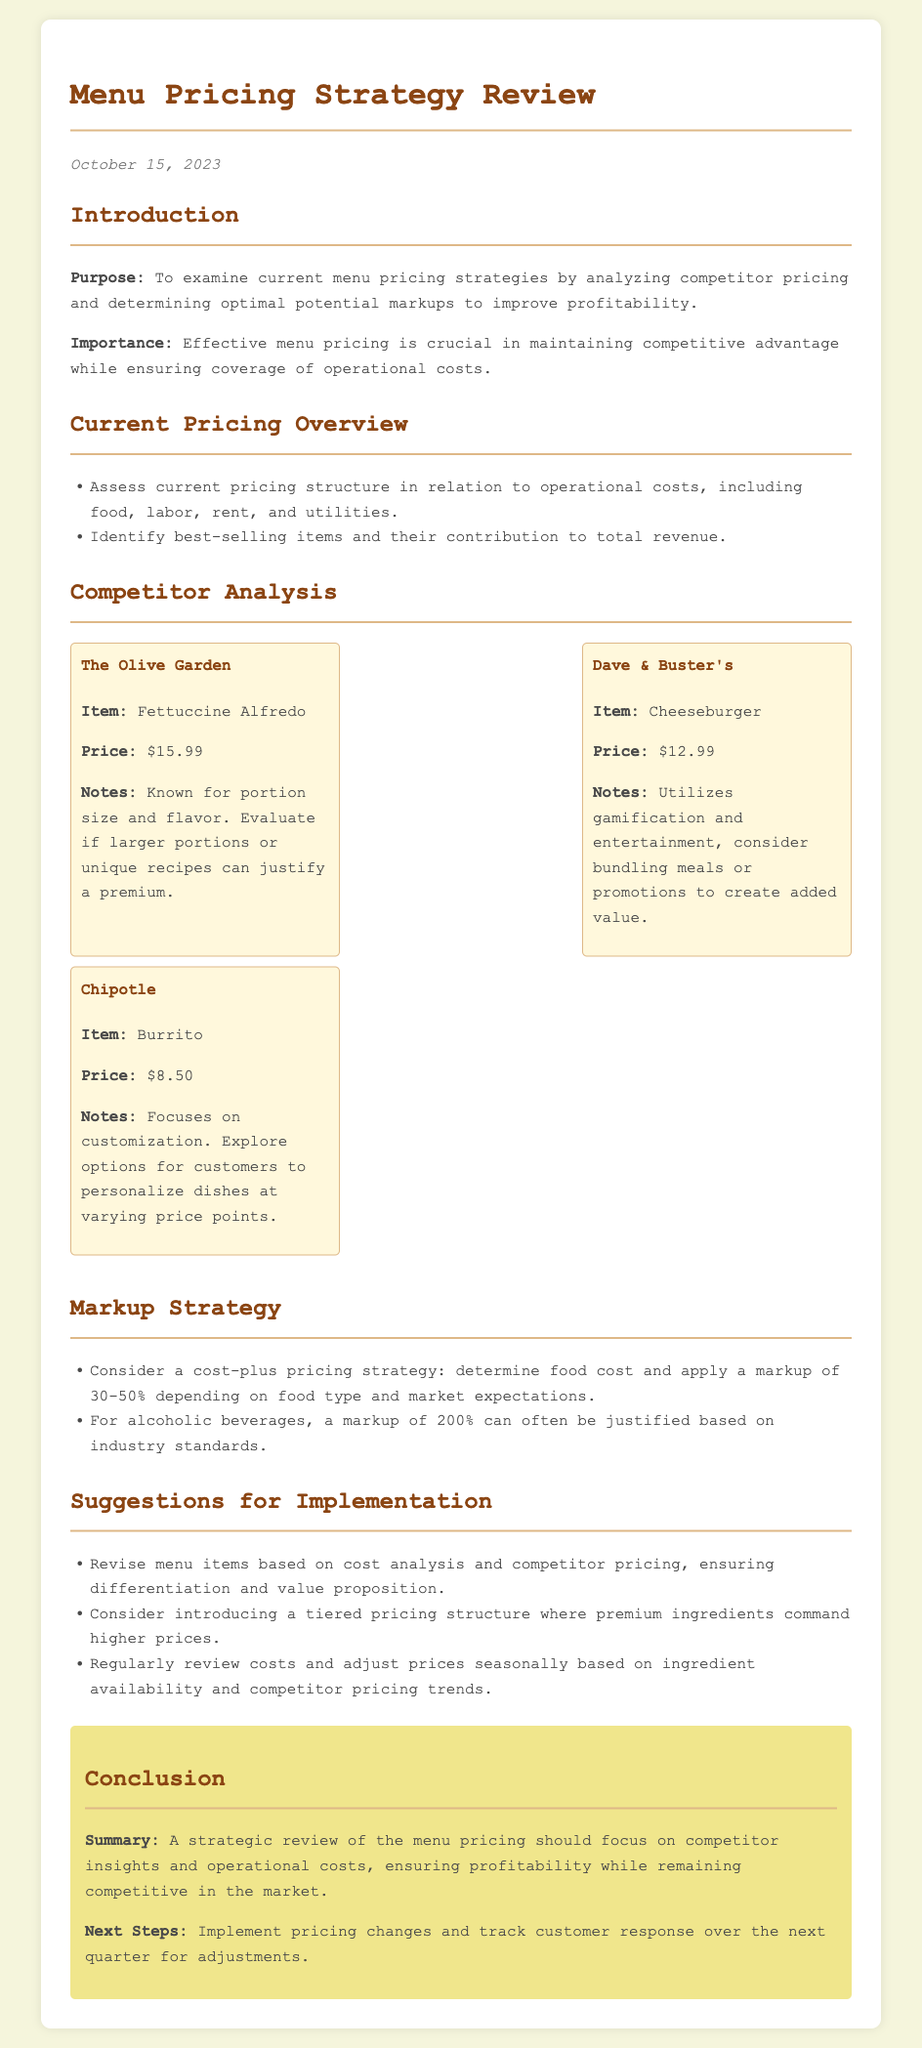What is the purpose of the document? The purpose is to examine current menu pricing strategies by analyzing competitor pricing and determining optimal potential markups to improve profitability.
Answer: To examine current menu pricing strategies What is the date of the review? The date is stated in the document as when the review was written, which is October 15, 2023.
Answer: October 15, 2023 Which competitor's item is priced at $12.99? The document lists the pricing and items from competitors, identifying that Dave & Buster's Cheeseburger is priced at $12.99.
Answer: Dave & Buster's What markup percentage is suggested for alcoholic beverages? The markup percentage mentioned for alcoholic beverages is based on industry standards, which is stated as 200%.
Answer: 200% What is included in the current pricing overview? The current pricing overview includes assessing pricing structure in relation to operational costs and identifying best-selling items contributing to total revenue.
Answer: Assess current pricing structure and identify best-selling items What suggestion is made regarding a tiered pricing structure? The suggestion involves introducing a tiered pricing structure where premium ingredients command higher prices, allowing for more pricing flexibility.
Answer: Introduce a tiered pricing structure Who is the competitor known for portion size and flavor? From the competitor analysis, it is noted that The Olive Garden is known for its portion size and flavor.
Answer: The Olive Garden What should be reviewed regularly according to the suggestions? The document suggests that regular reviews of costs and adjustments of prices should be made seasonally based on availability and competitor pricing trends.
Answer: Regularly review costs What does the conclusion emphasize? The conclusion emphasizes that a strategic review should focus on competitor insights and operational costs to ensure profitability while remaining competitive.
Answer: Focus on competitor insights and operational costs 